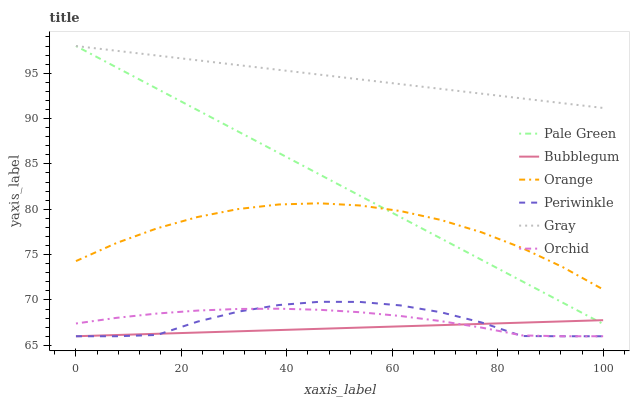Does Bubblegum have the minimum area under the curve?
Answer yes or no. Yes. Does Gray have the maximum area under the curve?
Answer yes or no. Yes. Does Pale Green have the minimum area under the curve?
Answer yes or no. No. Does Pale Green have the maximum area under the curve?
Answer yes or no. No. Is Gray the smoothest?
Answer yes or no. Yes. Is Periwinkle the roughest?
Answer yes or no. Yes. Is Bubblegum the smoothest?
Answer yes or no. No. Is Bubblegum the roughest?
Answer yes or no. No. Does Bubblegum have the lowest value?
Answer yes or no. Yes. Does Pale Green have the lowest value?
Answer yes or no. No. Does Pale Green have the highest value?
Answer yes or no. Yes. Does Bubblegum have the highest value?
Answer yes or no. No. Is Periwinkle less than Pale Green?
Answer yes or no. Yes. Is Orange greater than Orchid?
Answer yes or no. Yes. Does Pale Green intersect Gray?
Answer yes or no. Yes. Is Pale Green less than Gray?
Answer yes or no. No. Is Pale Green greater than Gray?
Answer yes or no. No. Does Periwinkle intersect Pale Green?
Answer yes or no. No. 